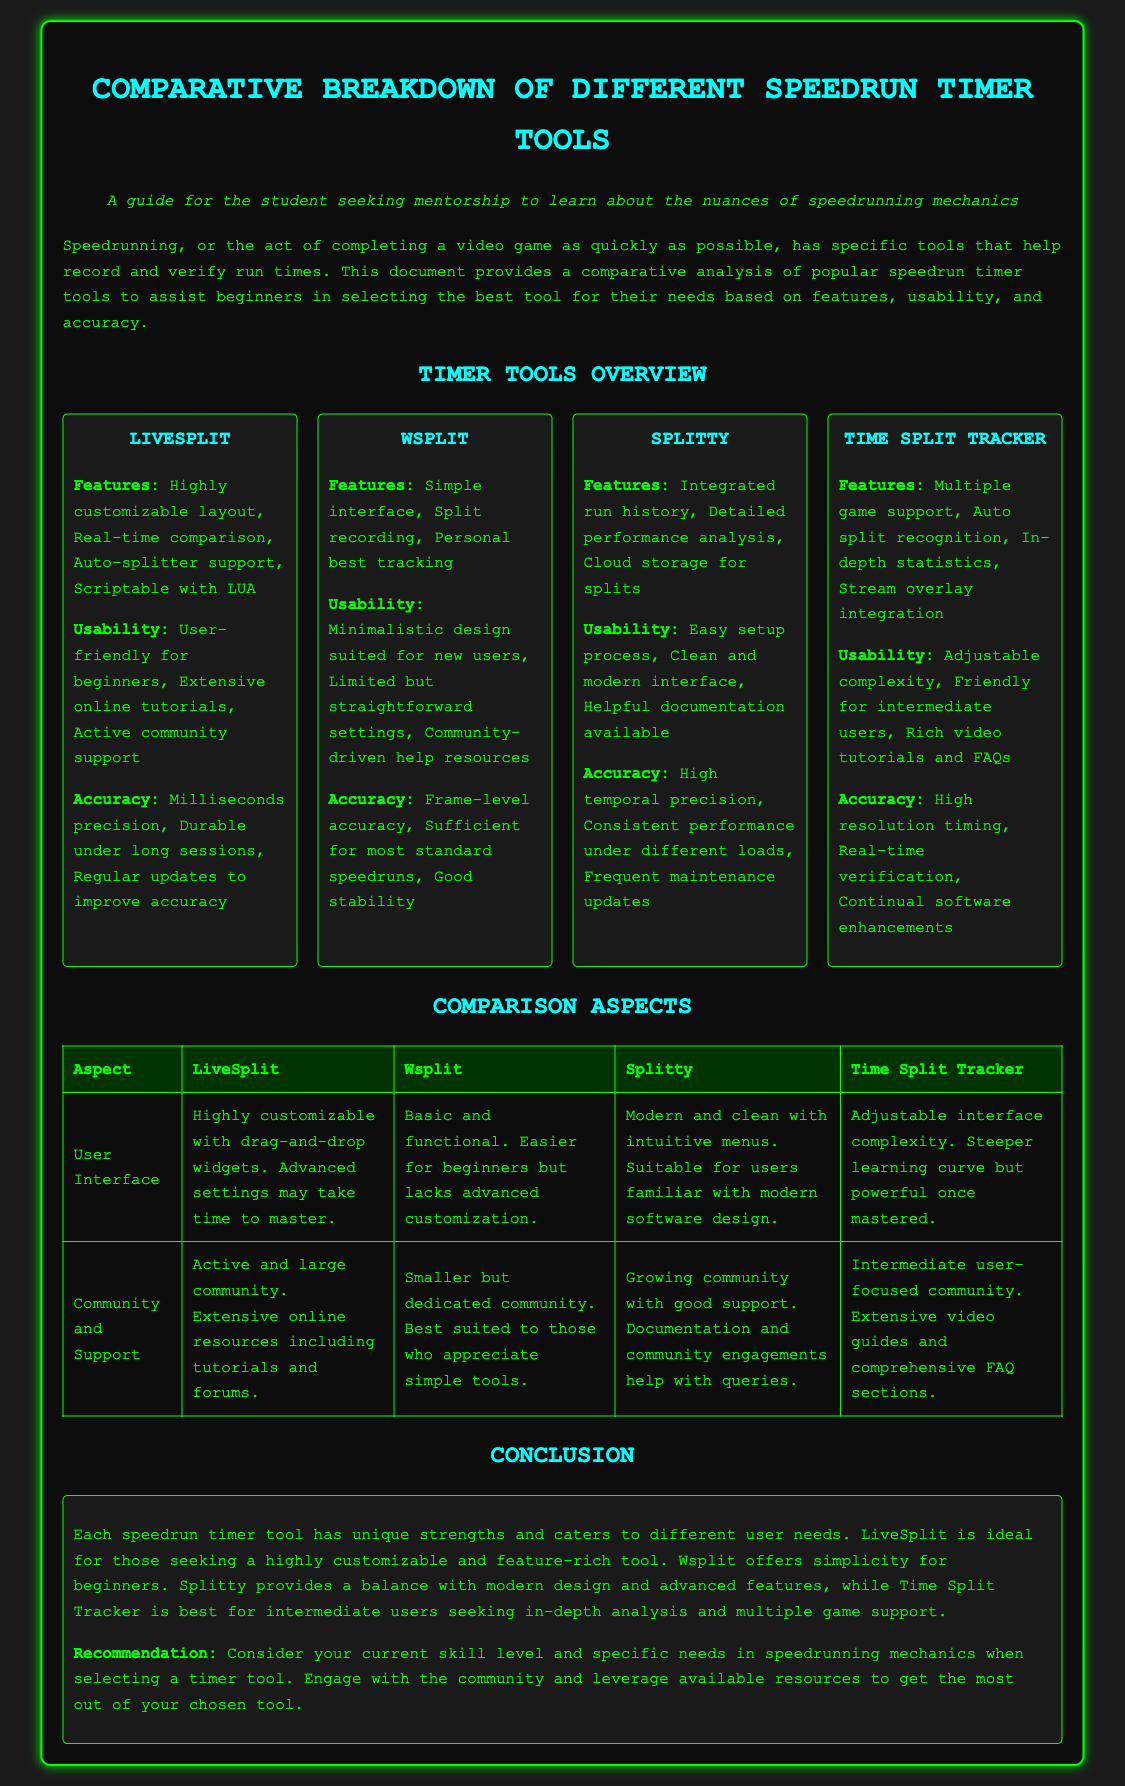What is the most feature-rich timer tool? The most feature-rich timer tool mentioned in the document is LiveSplit, which is described as ideal for those seeking a highly customizable and feature-rich tool.
Answer: LiveSplit Which timer tool has a simple interface? Wsplit is characterized as having a simple interface that is easy for new users to navigate.
Answer: Wsplit What is the accuracy level of Splitty? The document notes that Splitty has high temporal precision, indicating a strong level of accuracy.
Answer: High temporal precision Which tool supports auto-split recognition? Time Split Tracker is mentioned as having the feature of auto split recognition among its capabilities.
Answer: Time Split Tracker What type of community support does LiveSplit have? The community support for LiveSplit is described as active and large, providing extensive online resources including tutorials and forums.
Answer: Active and large community Which tool is recommended for beginners? The document recommends Wsplit for those seeking simplicity and a user-friendly experience suited for beginners.
Answer: Wsplit How many game support does Time Split Tracker offer? Time Split Tracker has multiple game support as one of its features according to the document.
Answer: Multiple game support What does the conclusion suggest about selecting a timer tool? The conclusion suggests considering current skill level and specific needs in speedrunning mechanics when selecting a timer tool.
Answer: Current skill level and specific needs What is a characteristic of Splitty’s user interface? Splitty's user interface is described as modern and clean with intuitive menus.
Answer: Modern and clean 